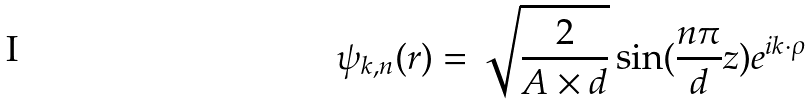Convert formula to latex. <formula><loc_0><loc_0><loc_500><loc_500>\psi _ { { k } , n } ( { r } ) = \sqrt { \frac { 2 } { A \times d } } \sin ( \frac { n \pi } { d } z ) e ^ { i { k } \cdot \rho }</formula> 